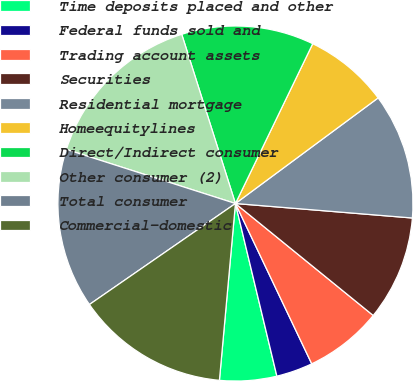Convert chart to OTSL. <chart><loc_0><loc_0><loc_500><loc_500><pie_chart><fcel>Time deposits placed and other<fcel>Federal funds sold and<fcel>Trading account assets<fcel>Securities<fcel>Residential mortgage<fcel>Homeequitylines<fcel>Direct/Indirect consumer<fcel>Other consumer (2)<fcel>Total consumer<fcel>Commercial-domestic<nl><fcel>5.19%<fcel>3.32%<fcel>7.07%<fcel>9.56%<fcel>11.44%<fcel>7.69%<fcel>12.06%<fcel>15.18%<fcel>14.56%<fcel>13.93%<nl></chart> 